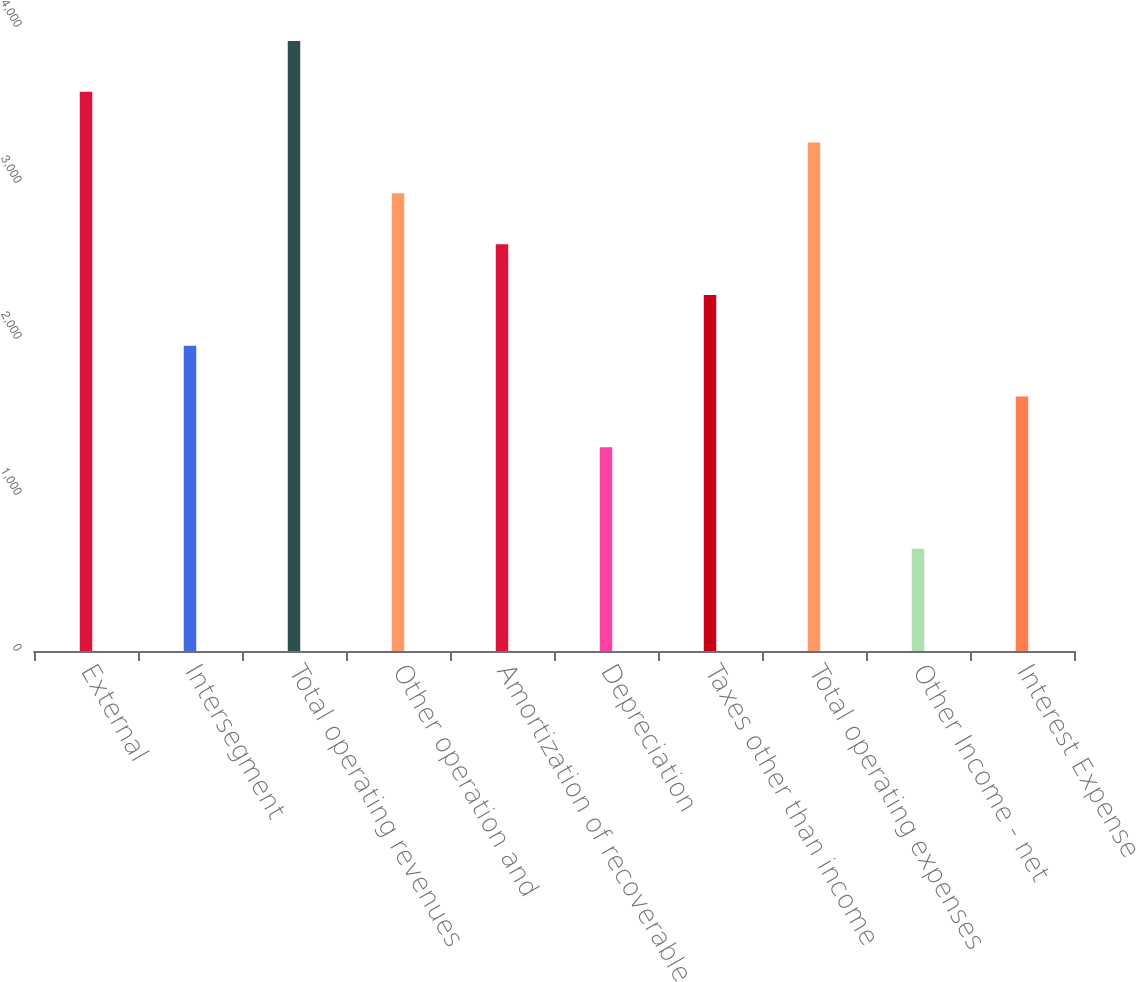Convert chart to OTSL. <chart><loc_0><loc_0><loc_500><loc_500><bar_chart><fcel>External<fcel>Intersegment<fcel>Total operating revenues<fcel>Other operation and<fcel>Amortization of recoverable<fcel>Depreciation<fcel>Taxes other than income<fcel>Total operating expenses<fcel>Other Income - net<fcel>Interest Expense<nl><fcel>3584.5<fcel>1957<fcel>3910<fcel>2933.5<fcel>2608<fcel>1306<fcel>2282.5<fcel>3259<fcel>655<fcel>1631.5<nl></chart> 